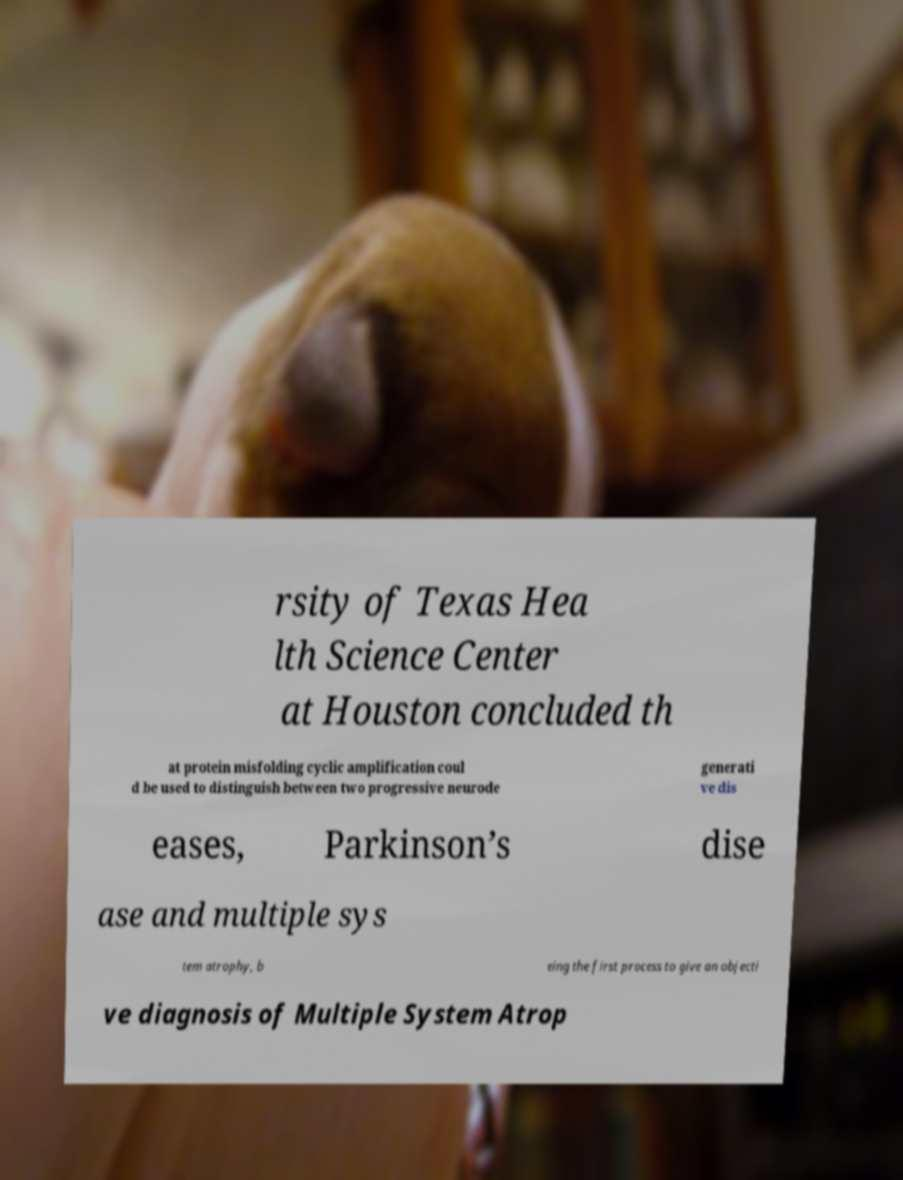What messages or text are displayed in this image? I need them in a readable, typed format. rsity of Texas Hea lth Science Center at Houston concluded th at protein misfolding cyclic amplification coul d be used to distinguish between two progressive neurode generati ve dis eases, Parkinson’s dise ase and multiple sys tem atrophy, b eing the first process to give an objecti ve diagnosis of Multiple System Atrop 